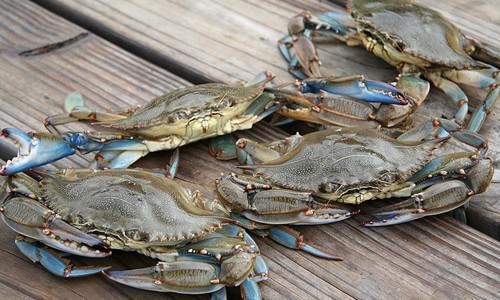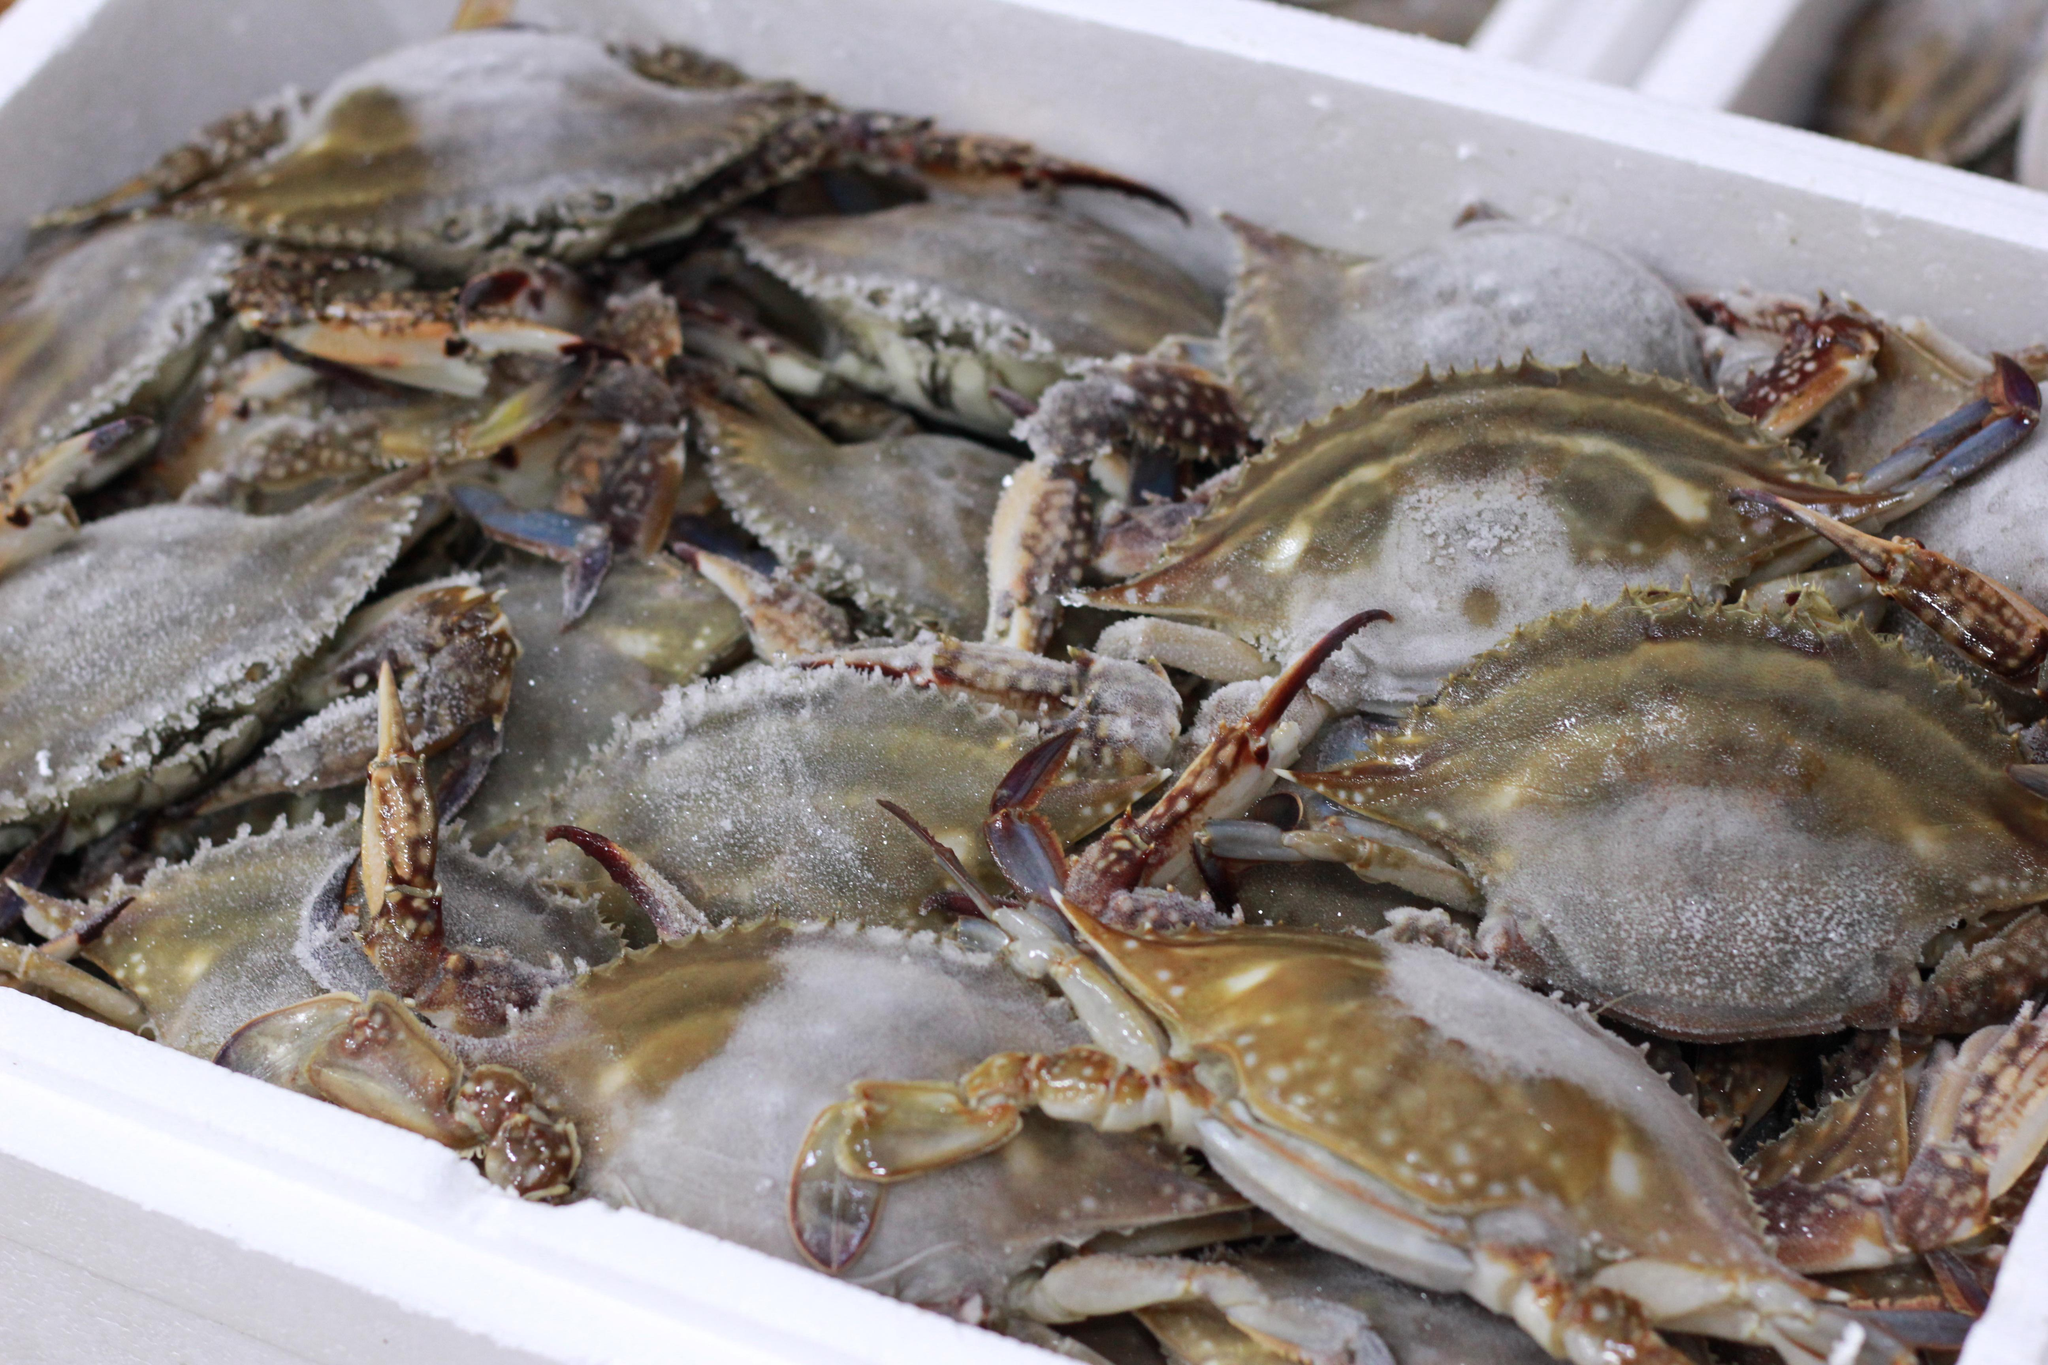The first image is the image on the left, the second image is the image on the right. Considering the images on both sides, is "The left image contains one forward-facing crab with its top shell visible, and the right image contains a mass of crabs." valid? Answer yes or no. No. The first image is the image on the left, the second image is the image on the right. For the images displayed, is the sentence "IN at least one image there is at least one blue clawed crab sitting on a wooden dock." factually correct? Answer yes or no. Yes. 